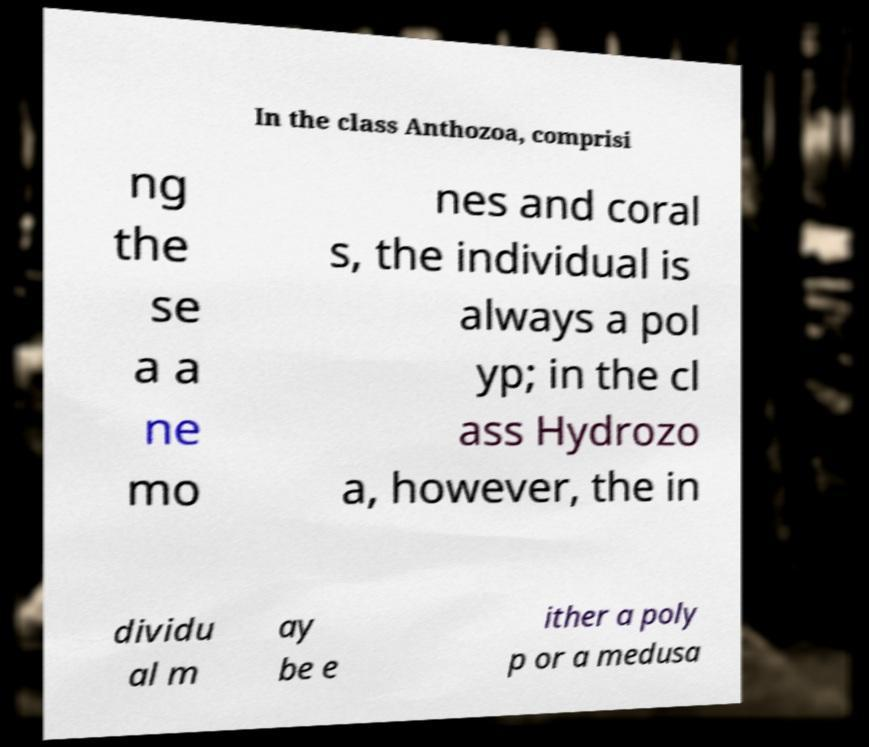Please read and relay the text visible in this image. What does it say? In the class Anthozoa, comprisi ng the se a a ne mo nes and coral s, the individual is always a pol yp; in the cl ass Hydrozo a, however, the in dividu al m ay be e ither a poly p or a medusa 